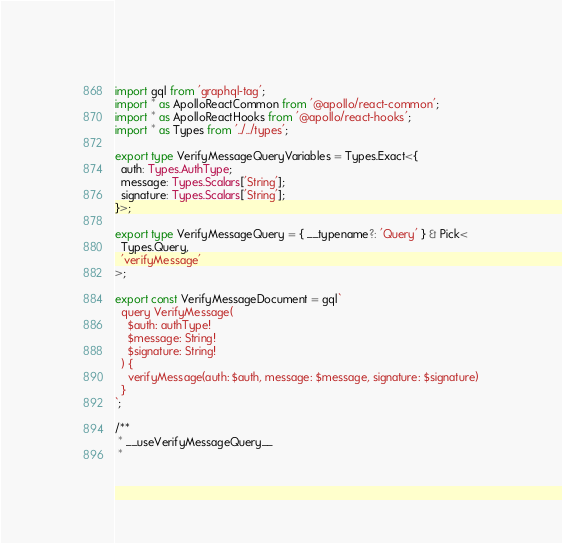Convert code to text. <code><loc_0><loc_0><loc_500><loc_500><_TypeScript_>import gql from 'graphql-tag';
import * as ApolloReactCommon from '@apollo/react-common';
import * as ApolloReactHooks from '@apollo/react-hooks';
import * as Types from '../../types';

export type VerifyMessageQueryVariables = Types.Exact<{
  auth: Types.AuthType;
  message: Types.Scalars['String'];
  signature: Types.Scalars['String'];
}>;

export type VerifyMessageQuery = { __typename?: 'Query' } & Pick<
  Types.Query,
  'verifyMessage'
>;

export const VerifyMessageDocument = gql`
  query VerifyMessage(
    $auth: authType!
    $message: String!
    $signature: String!
  ) {
    verifyMessage(auth: $auth, message: $message, signature: $signature)
  }
`;

/**
 * __useVerifyMessageQuery__
 *</code> 